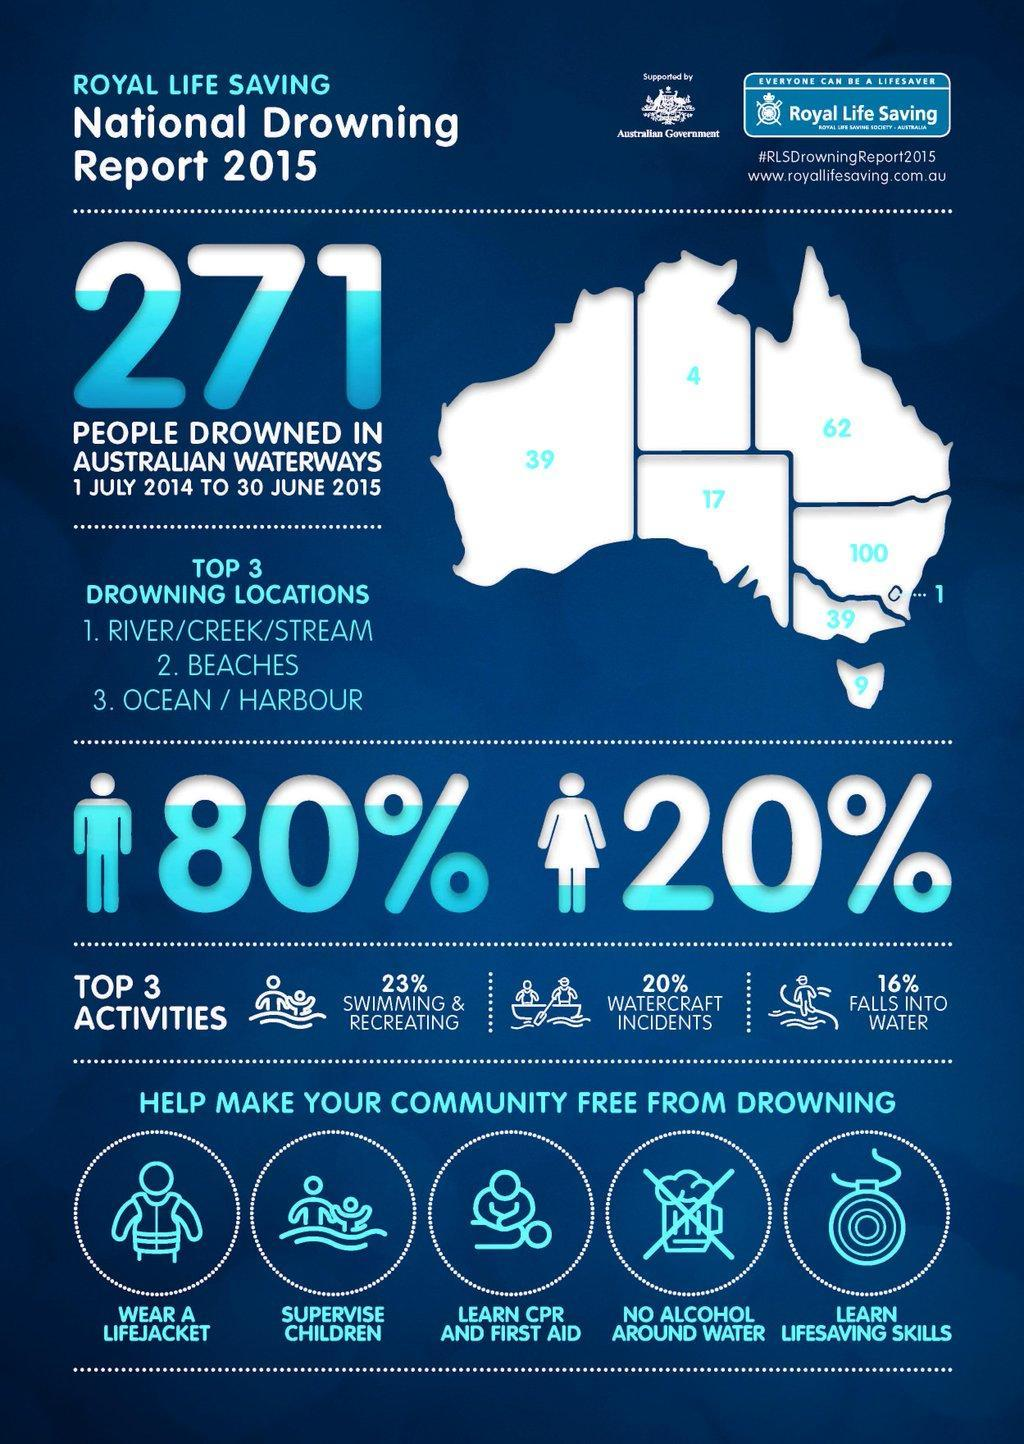What is the number of deaths due to drowning in Southern Australia?
Answer the question with a short phrase. 17 Which is the second highest cause that results in death due to drowning? Watercraft Incidents Which Australian region has the highest count of deaths, Queensland, New South Wales, or Victoria? New South Wales What should one keep away from while in water in order to avoid drowning deaths? No alcohol around water What is percentage difference in deaths between males and females due to drowning? 60% What is the number of deaths due to drowning in Western Australia? 39 